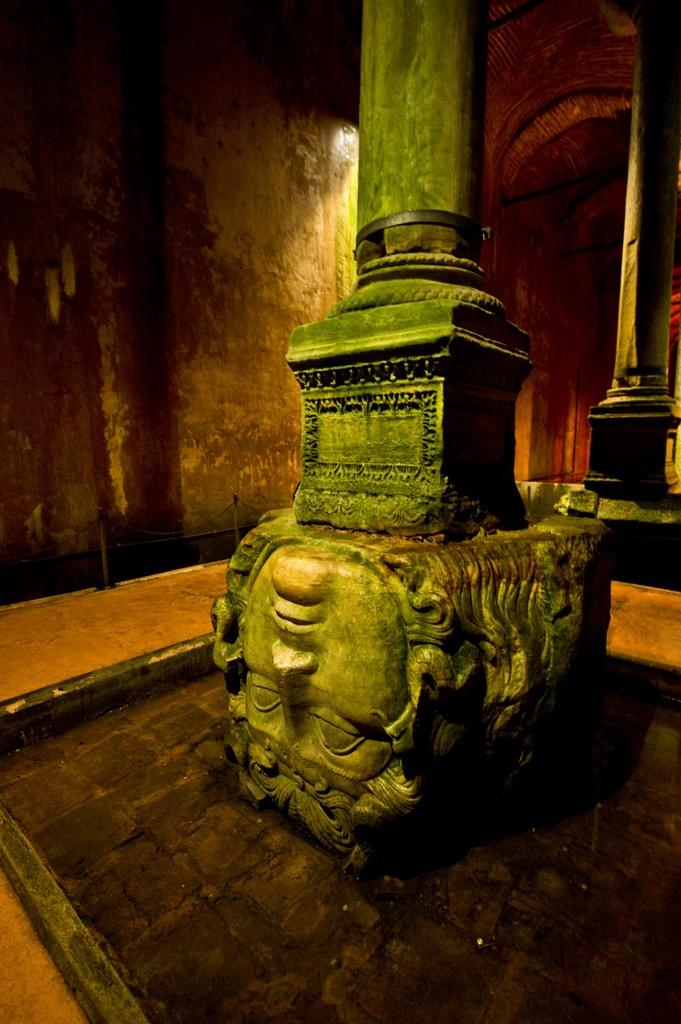What type of objects are depicted in the image? There are statues of faces in the image. What other objects can be seen in the image? There are poles in the image. What is visible in the background of the image? There is a wall and light visible in the background of the image. What type of letter is being delivered by the carriage in the image? There is no carriage or letter present in the image; it only features statues of faces and poles. 